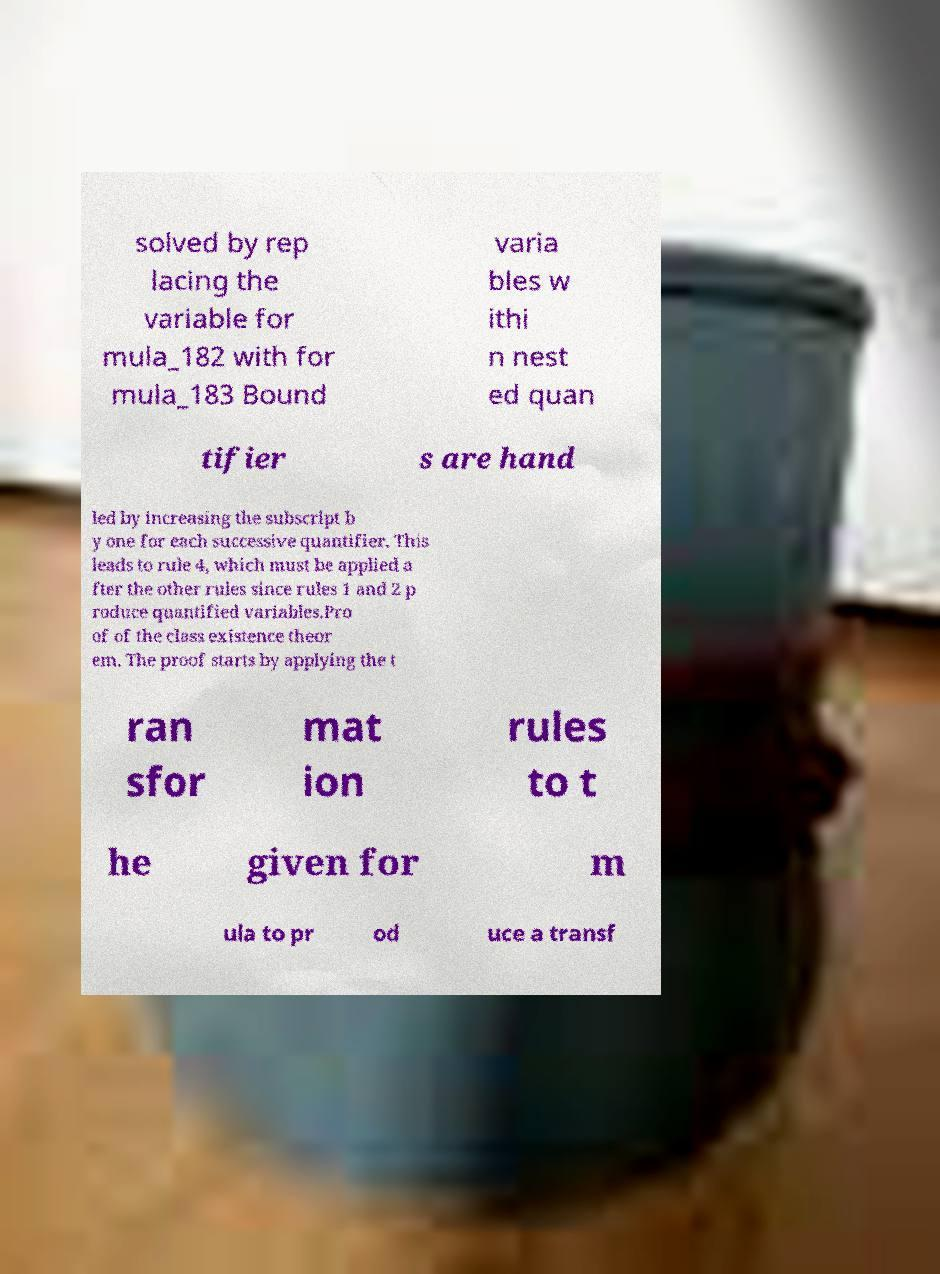Please read and relay the text visible in this image. What does it say? solved by rep lacing the variable for mula_182 with for mula_183 Bound varia bles w ithi n nest ed quan tifier s are hand led by increasing the subscript b y one for each successive quantifier. This leads to rule 4, which must be applied a fter the other rules since rules 1 and 2 p roduce quantified variables.Pro of of the class existence theor em. The proof starts by applying the t ran sfor mat ion rules to t he given for m ula to pr od uce a transf 